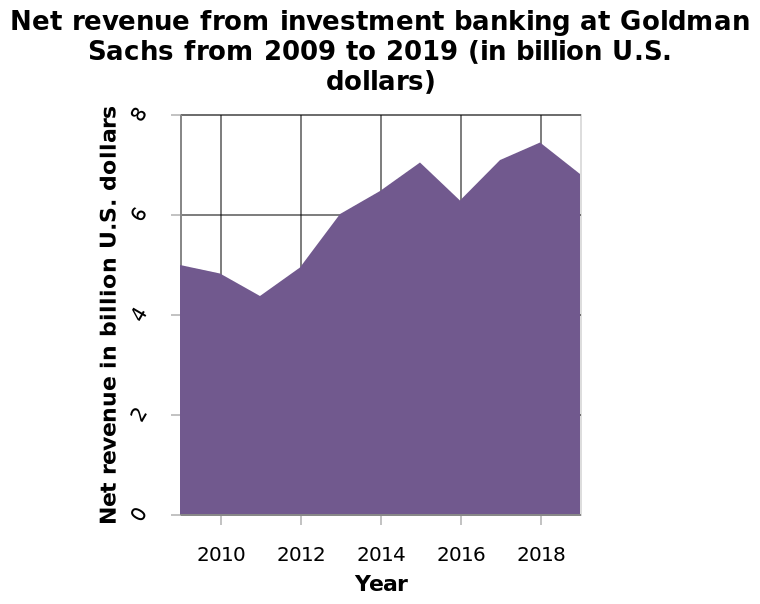<image>
What happened after the big decline?  After the big decline, there was a great recovery. please summary the statistics and relations of the chart An overall increase in net revenue over time. A decline in 2011 and 2016 before increasing again. Consistently over 6 million revenue since 2013. 